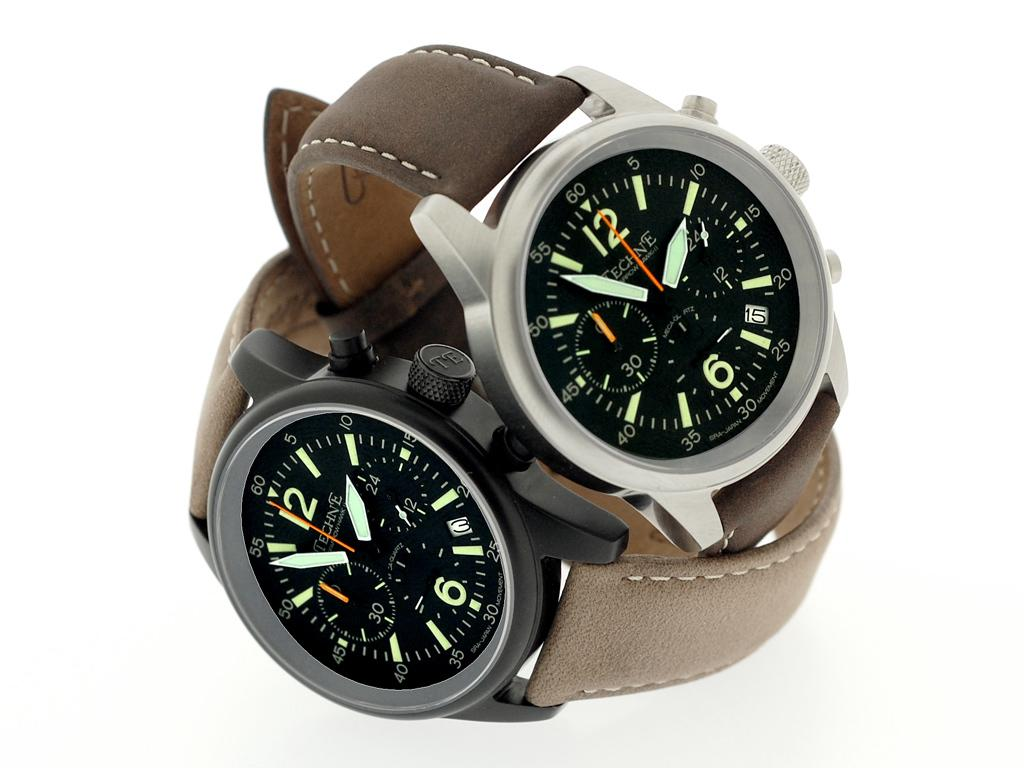<image>
Provide a brief description of the given image. Watch that says 1:54 with a dark background and minute hand pointing at 12. 